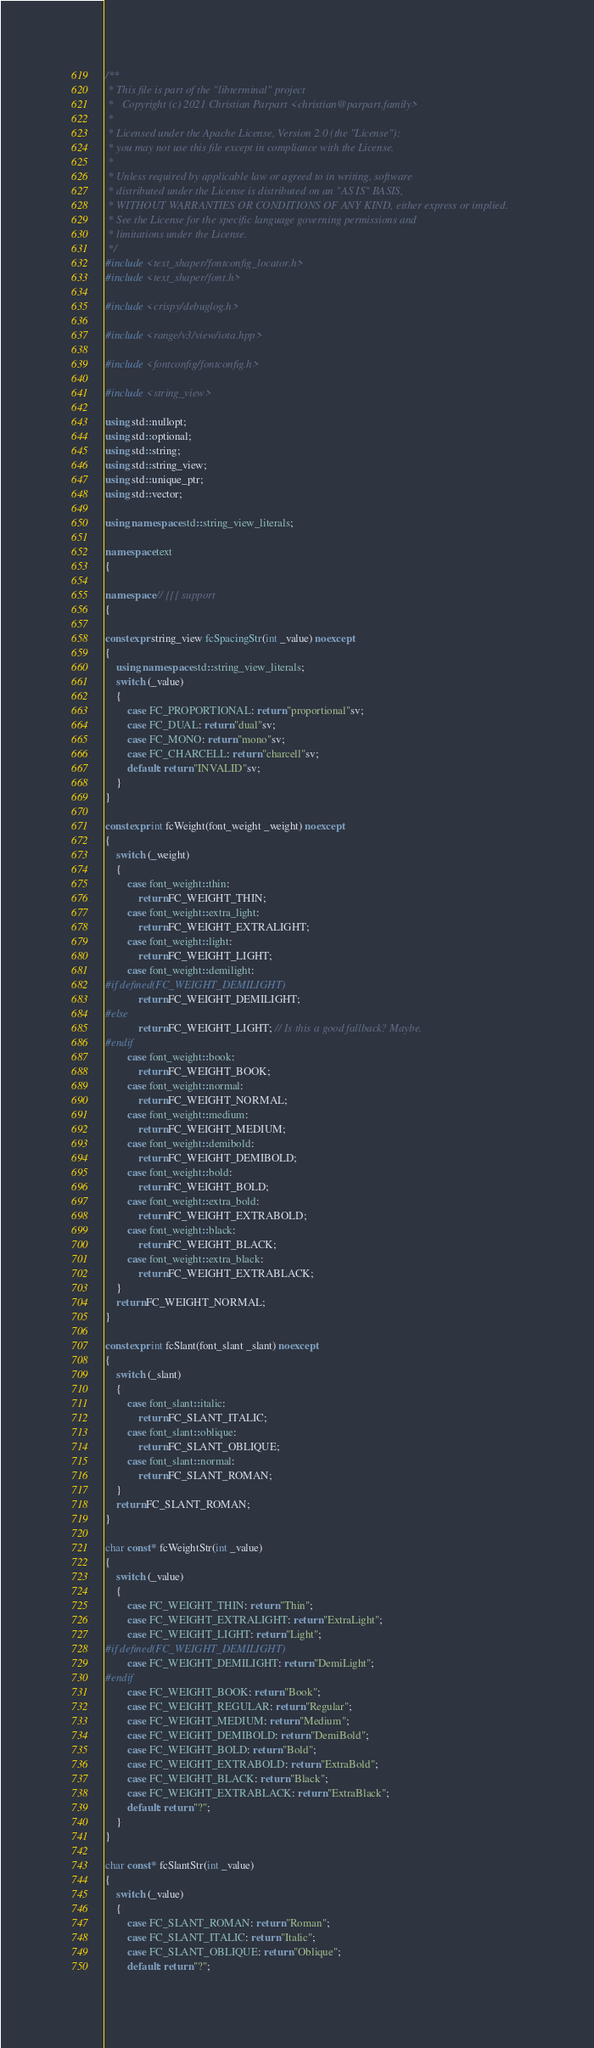<code> <loc_0><loc_0><loc_500><loc_500><_C++_>/**
 * This file is part of the "libterminal" project
 *   Copyright (c) 2021 Christian Parpart <christian@parpart.family>
 *
 * Licensed under the Apache License, Version 2.0 (the "License");
 * you may not use this file except in compliance with the License.
 *
 * Unless required by applicable law or agreed to in writing, software
 * distributed under the License is distributed on an "AS IS" BASIS,
 * WITHOUT WARRANTIES OR CONDITIONS OF ANY KIND, either express or implied.
 * See the License for the specific language governing permissions and
 * limitations under the License.
 */
#include <text_shaper/fontconfig_locator.h>
#include <text_shaper/font.h>

#include <crispy/debuglog.h>

#include <range/v3/view/iota.hpp>

#include <fontconfig/fontconfig.h>

#include <string_view>

using std::nullopt;
using std::optional;
using std::string;
using std::string_view;
using std::unique_ptr;
using std::vector;

using namespace std::string_view_literals;

namespace text
{

namespace // {{{ support
{

constexpr string_view fcSpacingStr(int _value) noexcept
{
    using namespace std::string_view_literals;
    switch (_value)
    {
        case FC_PROPORTIONAL: return "proportional"sv;
        case FC_DUAL: return "dual"sv;
        case FC_MONO: return "mono"sv;
        case FC_CHARCELL: return "charcell"sv;
        default: return "INVALID"sv;
    }
}

constexpr int fcWeight(font_weight _weight) noexcept
{
    switch (_weight)
    {
        case font_weight::thin:
            return FC_WEIGHT_THIN;
        case font_weight::extra_light:
            return FC_WEIGHT_EXTRALIGHT;
        case font_weight::light:
            return FC_WEIGHT_LIGHT;
        case font_weight::demilight:
#if defined(FC_WEIGHT_DEMILIGHT)
            return FC_WEIGHT_DEMILIGHT;
#else
            return FC_WEIGHT_LIGHT; // Is this a good fallback? Maybe.
#endif
        case font_weight::book:
            return FC_WEIGHT_BOOK;
        case font_weight::normal:
            return FC_WEIGHT_NORMAL;
        case font_weight::medium:
            return FC_WEIGHT_MEDIUM;
        case font_weight::demibold:
            return FC_WEIGHT_DEMIBOLD;
        case font_weight::bold:
            return FC_WEIGHT_BOLD;
        case font_weight::extra_bold:
            return FC_WEIGHT_EXTRABOLD;
        case font_weight::black:
            return FC_WEIGHT_BLACK;
        case font_weight::extra_black:
            return FC_WEIGHT_EXTRABLACK;
    }
    return FC_WEIGHT_NORMAL;
}

constexpr int fcSlant(font_slant _slant) noexcept
{
    switch (_slant)
    {
        case font_slant::italic:
            return FC_SLANT_ITALIC;
        case font_slant::oblique:
            return FC_SLANT_OBLIQUE;
        case font_slant::normal:
            return FC_SLANT_ROMAN;
    }
    return FC_SLANT_ROMAN;
}

char const* fcWeightStr(int _value)
{
    switch (_value)
    {
        case FC_WEIGHT_THIN: return "Thin";
        case FC_WEIGHT_EXTRALIGHT: return "ExtraLight";
        case FC_WEIGHT_LIGHT: return "Light";
#if defined(FC_WEIGHT_DEMILIGHT)
        case FC_WEIGHT_DEMILIGHT: return "DemiLight";
#endif
        case FC_WEIGHT_BOOK: return "Book";
        case FC_WEIGHT_REGULAR: return "Regular";
        case FC_WEIGHT_MEDIUM: return "Medium";
        case FC_WEIGHT_DEMIBOLD: return "DemiBold";
        case FC_WEIGHT_BOLD: return "Bold";
        case FC_WEIGHT_EXTRABOLD: return "ExtraBold";
        case FC_WEIGHT_BLACK: return "Black";
        case FC_WEIGHT_EXTRABLACK: return "ExtraBlack";
        default: return "?";
    }
}

char const* fcSlantStr(int _value)
{
    switch (_value)
    {
        case FC_SLANT_ROMAN: return "Roman";
        case FC_SLANT_ITALIC: return "Italic";
        case FC_SLANT_OBLIQUE: return "Oblique";
        default: return "?";</code> 